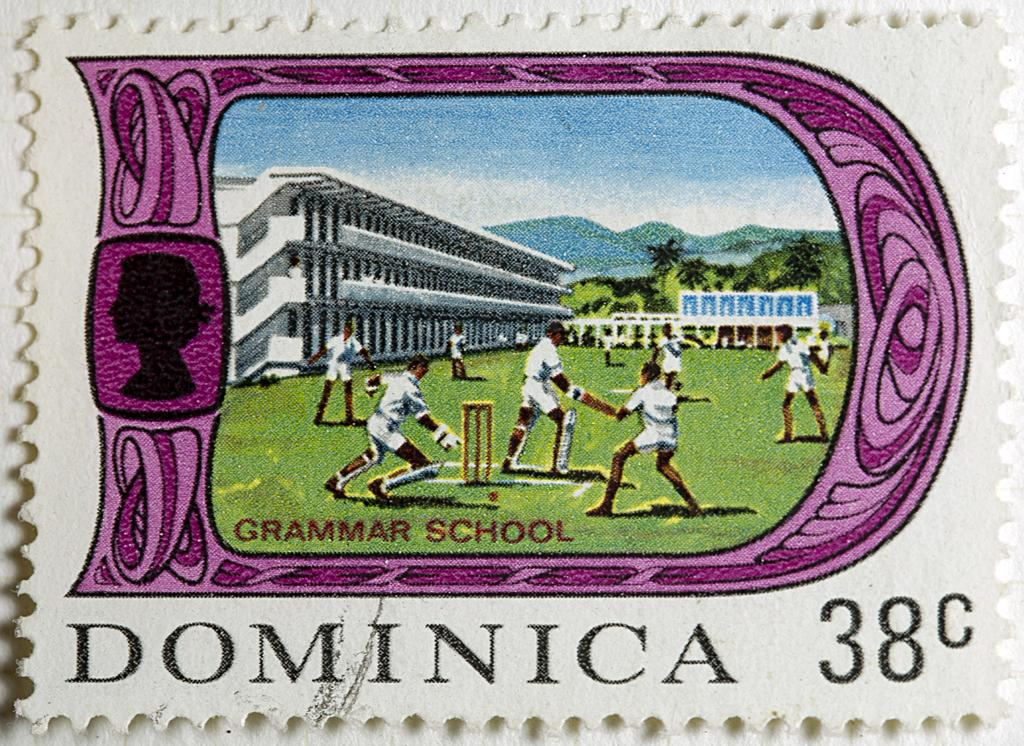<image>
Relay a brief, clear account of the picture shown. A stamp from Dominica that's worth 38 cents shows people playing cricket. 